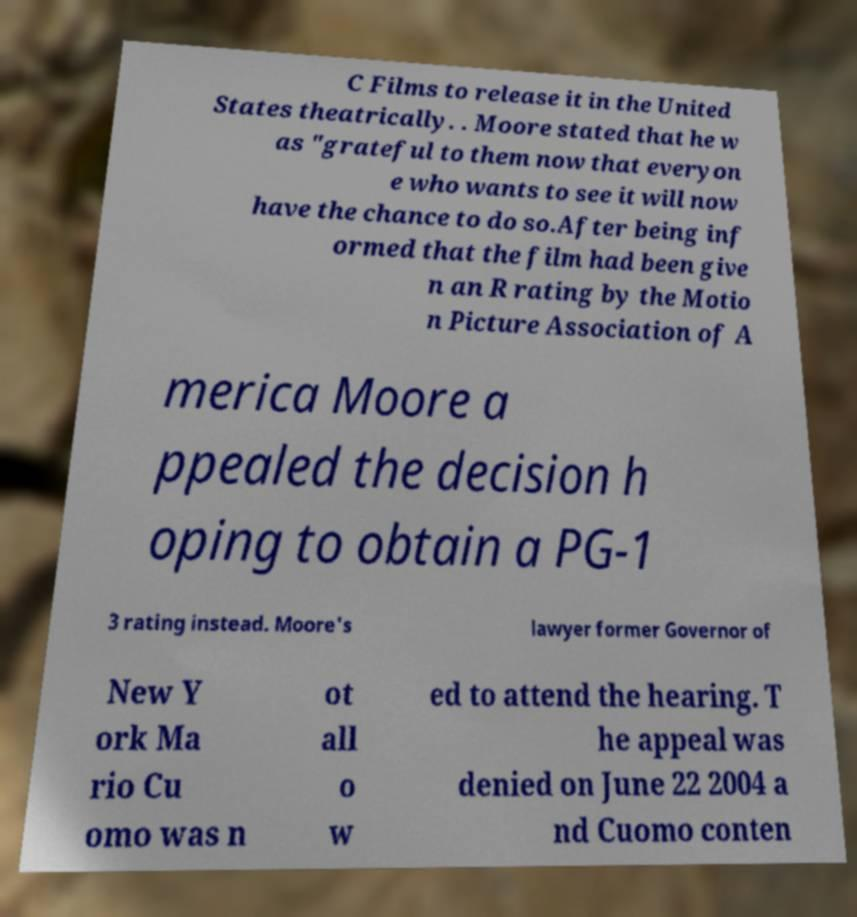Can you accurately transcribe the text from the provided image for me? C Films to release it in the United States theatrically. . Moore stated that he w as "grateful to them now that everyon e who wants to see it will now have the chance to do so.After being inf ormed that the film had been give n an R rating by the Motio n Picture Association of A merica Moore a ppealed the decision h oping to obtain a PG-1 3 rating instead. Moore's lawyer former Governor of New Y ork Ma rio Cu omo was n ot all o w ed to attend the hearing. T he appeal was denied on June 22 2004 a nd Cuomo conten 